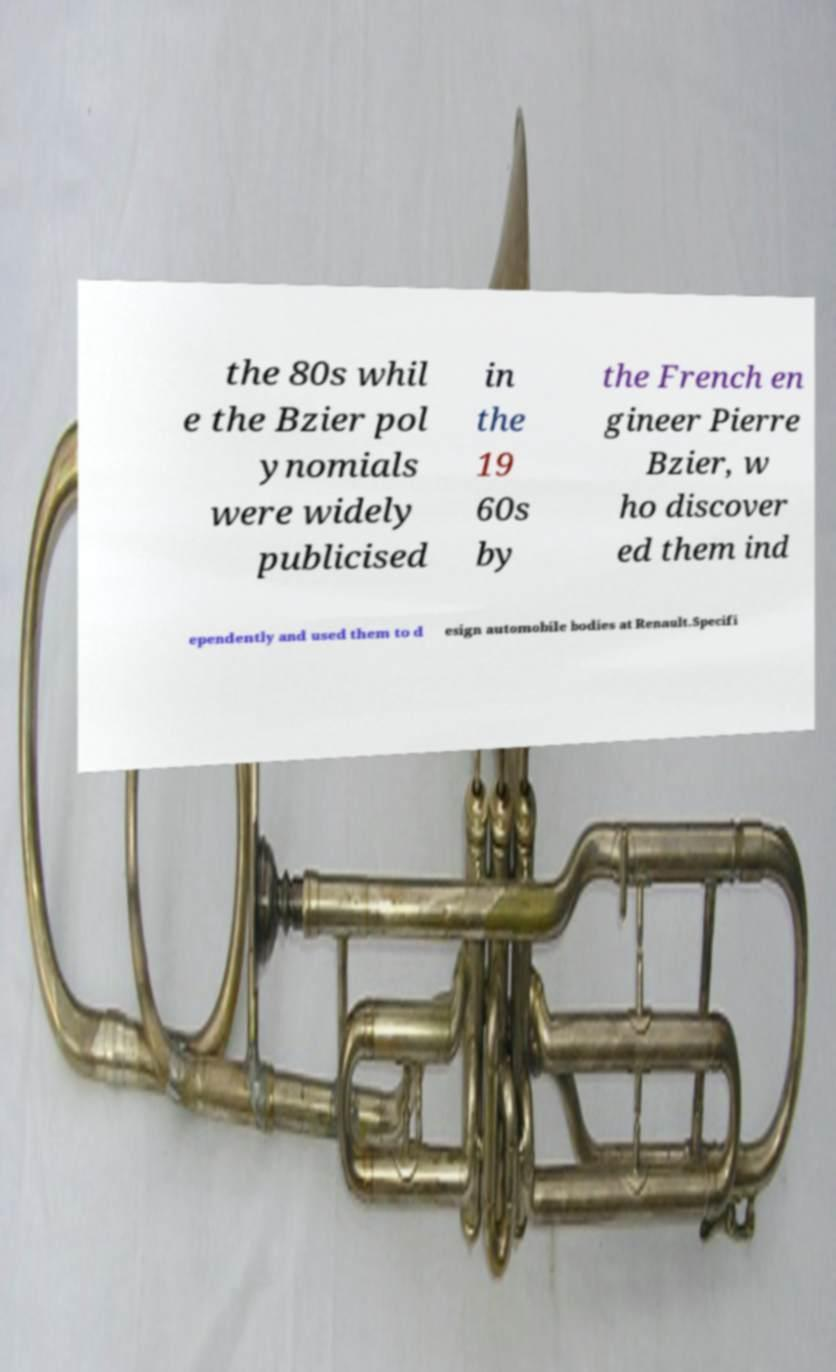Can you accurately transcribe the text from the provided image for me? the 80s whil e the Bzier pol ynomials were widely publicised in the 19 60s by the French en gineer Pierre Bzier, w ho discover ed them ind ependently and used them to d esign automobile bodies at Renault.Specifi 